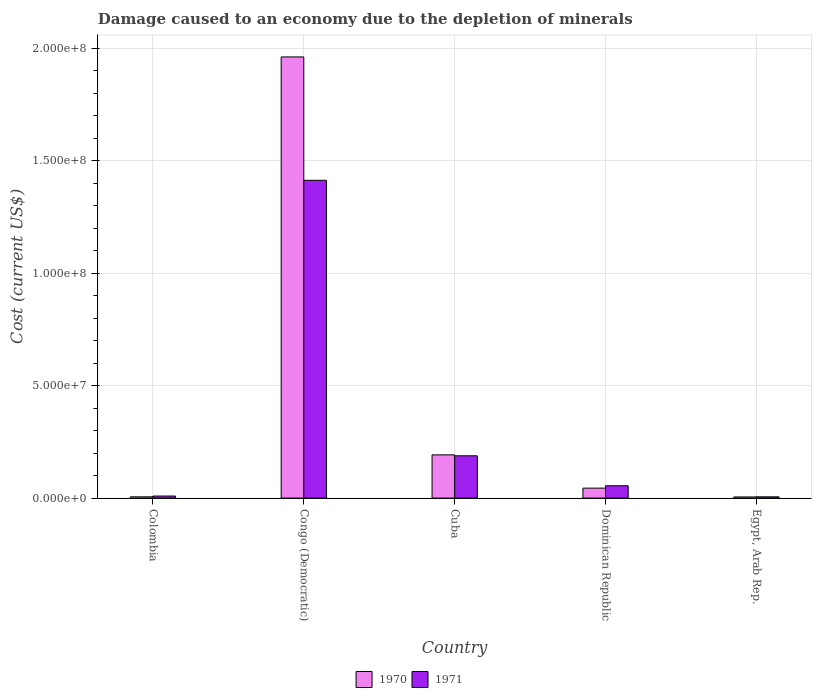How many different coloured bars are there?
Your response must be concise. 2. Are the number of bars on each tick of the X-axis equal?
Offer a very short reply. Yes. How many bars are there on the 5th tick from the right?
Offer a terse response. 2. What is the label of the 5th group of bars from the left?
Offer a terse response. Egypt, Arab Rep. What is the cost of damage caused due to the depletion of minerals in 1971 in Egypt, Arab Rep.?
Offer a very short reply. 5.55e+05. Across all countries, what is the maximum cost of damage caused due to the depletion of minerals in 1971?
Your answer should be compact. 1.41e+08. Across all countries, what is the minimum cost of damage caused due to the depletion of minerals in 1970?
Provide a short and direct response. 5.07e+05. In which country was the cost of damage caused due to the depletion of minerals in 1970 maximum?
Your answer should be very brief. Congo (Democratic). In which country was the cost of damage caused due to the depletion of minerals in 1970 minimum?
Make the answer very short. Egypt, Arab Rep. What is the total cost of damage caused due to the depletion of minerals in 1971 in the graph?
Offer a very short reply. 1.67e+08. What is the difference between the cost of damage caused due to the depletion of minerals in 1971 in Congo (Democratic) and that in Egypt, Arab Rep.?
Ensure brevity in your answer.  1.41e+08. What is the difference between the cost of damage caused due to the depletion of minerals in 1971 in Colombia and the cost of damage caused due to the depletion of minerals in 1970 in Cuba?
Your answer should be very brief. -1.83e+07. What is the average cost of damage caused due to the depletion of minerals in 1971 per country?
Provide a succinct answer. 3.34e+07. What is the difference between the cost of damage caused due to the depletion of minerals of/in 1970 and cost of damage caused due to the depletion of minerals of/in 1971 in Cuba?
Your answer should be very brief. 4.14e+05. In how many countries, is the cost of damage caused due to the depletion of minerals in 1971 greater than 150000000 US$?
Offer a terse response. 0. What is the ratio of the cost of damage caused due to the depletion of minerals in 1970 in Colombia to that in Egypt, Arab Rep.?
Your response must be concise. 1.09. Is the difference between the cost of damage caused due to the depletion of minerals in 1970 in Congo (Democratic) and Egypt, Arab Rep. greater than the difference between the cost of damage caused due to the depletion of minerals in 1971 in Congo (Democratic) and Egypt, Arab Rep.?
Your response must be concise. Yes. What is the difference between the highest and the second highest cost of damage caused due to the depletion of minerals in 1970?
Provide a short and direct response. -1.77e+08. What is the difference between the highest and the lowest cost of damage caused due to the depletion of minerals in 1971?
Ensure brevity in your answer.  1.41e+08. What does the 1st bar from the left in Congo (Democratic) represents?
Provide a short and direct response. 1970. What does the 2nd bar from the right in Congo (Democratic) represents?
Provide a succinct answer. 1970. How many bars are there?
Ensure brevity in your answer.  10. Are all the bars in the graph horizontal?
Give a very brief answer. No. How many countries are there in the graph?
Ensure brevity in your answer.  5. Are the values on the major ticks of Y-axis written in scientific E-notation?
Give a very brief answer. Yes. Does the graph contain grids?
Keep it short and to the point. Yes. Where does the legend appear in the graph?
Your response must be concise. Bottom center. How many legend labels are there?
Your answer should be compact. 2. What is the title of the graph?
Make the answer very short. Damage caused to an economy due to the depletion of minerals. Does "1962" appear as one of the legend labels in the graph?
Keep it short and to the point. No. What is the label or title of the Y-axis?
Keep it short and to the point. Cost (current US$). What is the Cost (current US$) of 1970 in Colombia?
Provide a short and direct response. 5.53e+05. What is the Cost (current US$) of 1971 in Colombia?
Your answer should be compact. 9.12e+05. What is the Cost (current US$) in 1970 in Congo (Democratic)?
Ensure brevity in your answer.  1.96e+08. What is the Cost (current US$) in 1971 in Congo (Democratic)?
Provide a short and direct response. 1.41e+08. What is the Cost (current US$) in 1970 in Cuba?
Provide a succinct answer. 1.92e+07. What is the Cost (current US$) of 1971 in Cuba?
Give a very brief answer. 1.88e+07. What is the Cost (current US$) of 1970 in Dominican Republic?
Make the answer very short. 4.43e+06. What is the Cost (current US$) in 1971 in Dominican Republic?
Your answer should be very brief. 5.48e+06. What is the Cost (current US$) of 1970 in Egypt, Arab Rep.?
Your answer should be very brief. 5.07e+05. What is the Cost (current US$) in 1971 in Egypt, Arab Rep.?
Give a very brief answer. 5.55e+05. Across all countries, what is the maximum Cost (current US$) in 1970?
Your answer should be compact. 1.96e+08. Across all countries, what is the maximum Cost (current US$) in 1971?
Ensure brevity in your answer.  1.41e+08. Across all countries, what is the minimum Cost (current US$) in 1970?
Your answer should be very brief. 5.07e+05. Across all countries, what is the minimum Cost (current US$) of 1971?
Provide a short and direct response. 5.55e+05. What is the total Cost (current US$) of 1970 in the graph?
Your answer should be very brief. 2.21e+08. What is the total Cost (current US$) in 1971 in the graph?
Offer a terse response. 1.67e+08. What is the difference between the Cost (current US$) of 1970 in Colombia and that in Congo (Democratic)?
Keep it short and to the point. -1.96e+08. What is the difference between the Cost (current US$) in 1971 in Colombia and that in Congo (Democratic)?
Your response must be concise. -1.40e+08. What is the difference between the Cost (current US$) in 1970 in Colombia and that in Cuba?
Your response must be concise. -1.87e+07. What is the difference between the Cost (current US$) in 1971 in Colombia and that in Cuba?
Provide a short and direct response. -1.79e+07. What is the difference between the Cost (current US$) of 1970 in Colombia and that in Dominican Republic?
Keep it short and to the point. -3.87e+06. What is the difference between the Cost (current US$) of 1971 in Colombia and that in Dominican Republic?
Ensure brevity in your answer.  -4.57e+06. What is the difference between the Cost (current US$) of 1970 in Colombia and that in Egypt, Arab Rep.?
Offer a terse response. 4.53e+04. What is the difference between the Cost (current US$) in 1971 in Colombia and that in Egypt, Arab Rep.?
Your answer should be compact. 3.57e+05. What is the difference between the Cost (current US$) of 1970 in Congo (Democratic) and that in Cuba?
Your answer should be very brief. 1.77e+08. What is the difference between the Cost (current US$) in 1971 in Congo (Democratic) and that in Cuba?
Give a very brief answer. 1.23e+08. What is the difference between the Cost (current US$) in 1970 in Congo (Democratic) and that in Dominican Republic?
Your answer should be very brief. 1.92e+08. What is the difference between the Cost (current US$) of 1971 in Congo (Democratic) and that in Dominican Republic?
Your answer should be compact. 1.36e+08. What is the difference between the Cost (current US$) of 1970 in Congo (Democratic) and that in Egypt, Arab Rep.?
Give a very brief answer. 1.96e+08. What is the difference between the Cost (current US$) of 1971 in Congo (Democratic) and that in Egypt, Arab Rep.?
Offer a very short reply. 1.41e+08. What is the difference between the Cost (current US$) of 1970 in Cuba and that in Dominican Republic?
Your answer should be compact. 1.48e+07. What is the difference between the Cost (current US$) of 1971 in Cuba and that in Dominican Republic?
Your answer should be compact. 1.33e+07. What is the difference between the Cost (current US$) in 1970 in Cuba and that in Egypt, Arab Rep.?
Offer a terse response. 1.87e+07. What is the difference between the Cost (current US$) in 1971 in Cuba and that in Egypt, Arab Rep.?
Ensure brevity in your answer.  1.83e+07. What is the difference between the Cost (current US$) of 1970 in Dominican Republic and that in Egypt, Arab Rep.?
Offer a very short reply. 3.92e+06. What is the difference between the Cost (current US$) of 1971 in Dominican Republic and that in Egypt, Arab Rep.?
Give a very brief answer. 4.92e+06. What is the difference between the Cost (current US$) of 1970 in Colombia and the Cost (current US$) of 1971 in Congo (Democratic)?
Ensure brevity in your answer.  -1.41e+08. What is the difference between the Cost (current US$) of 1970 in Colombia and the Cost (current US$) of 1971 in Cuba?
Make the answer very short. -1.83e+07. What is the difference between the Cost (current US$) in 1970 in Colombia and the Cost (current US$) in 1971 in Dominican Republic?
Provide a short and direct response. -4.93e+06. What is the difference between the Cost (current US$) in 1970 in Colombia and the Cost (current US$) in 1971 in Egypt, Arab Rep.?
Ensure brevity in your answer.  -2551.4. What is the difference between the Cost (current US$) in 1970 in Congo (Democratic) and the Cost (current US$) in 1971 in Cuba?
Provide a succinct answer. 1.77e+08. What is the difference between the Cost (current US$) in 1970 in Congo (Democratic) and the Cost (current US$) in 1971 in Dominican Republic?
Your answer should be very brief. 1.91e+08. What is the difference between the Cost (current US$) of 1970 in Congo (Democratic) and the Cost (current US$) of 1971 in Egypt, Arab Rep.?
Provide a short and direct response. 1.96e+08. What is the difference between the Cost (current US$) in 1970 in Cuba and the Cost (current US$) in 1971 in Dominican Republic?
Offer a very short reply. 1.37e+07. What is the difference between the Cost (current US$) in 1970 in Cuba and the Cost (current US$) in 1971 in Egypt, Arab Rep.?
Your response must be concise. 1.87e+07. What is the difference between the Cost (current US$) of 1970 in Dominican Republic and the Cost (current US$) of 1971 in Egypt, Arab Rep.?
Provide a short and direct response. 3.87e+06. What is the average Cost (current US$) in 1970 per country?
Provide a short and direct response. 4.42e+07. What is the average Cost (current US$) of 1971 per country?
Make the answer very short. 3.34e+07. What is the difference between the Cost (current US$) in 1970 and Cost (current US$) in 1971 in Colombia?
Give a very brief answer. -3.59e+05. What is the difference between the Cost (current US$) of 1970 and Cost (current US$) of 1971 in Congo (Democratic)?
Ensure brevity in your answer.  5.49e+07. What is the difference between the Cost (current US$) of 1970 and Cost (current US$) of 1971 in Cuba?
Give a very brief answer. 4.14e+05. What is the difference between the Cost (current US$) in 1970 and Cost (current US$) in 1971 in Dominican Republic?
Your answer should be very brief. -1.05e+06. What is the difference between the Cost (current US$) in 1970 and Cost (current US$) in 1971 in Egypt, Arab Rep.?
Ensure brevity in your answer.  -4.79e+04. What is the ratio of the Cost (current US$) in 1970 in Colombia to that in Congo (Democratic)?
Give a very brief answer. 0. What is the ratio of the Cost (current US$) in 1971 in Colombia to that in Congo (Democratic)?
Make the answer very short. 0.01. What is the ratio of the Cost (current US$) in 1970 in Colombia to that in Cuba?
Your answer should be very brief. 0.03. What is the ratio of the Cost (current US$) of 1971 in Colombia to that in Cuba?
Provide a succinct answer. 0.05. What is the ratio of the Cost (current US$) of 1970 in Colombia to that in Dominican Republic?
Provide a succinct answer. 0.12. What is the ratio of the Cost (current US$) of 1971 in Colombia to that in Dominican Republic?
Provide a succinct answer. 0.17. What is the ratio of the Cost (current US$) of 1970 in Colombia to that in Egypt, Arab Rep.?
Provide a succinct answer. 1.09. What is the ratio of the Cost (current US$) in 1971 in Colombia to that in Egypt, Arab Rep.?
Provide a short and direct response. 1.64. What is the ratio of the Cost (current US$) in 1970 in Congo (Democratic) to that in Cuba?
Your answer should be compact. 10.21. What is the ratio of the Cost (current US$) in 1971 in Congo (Democratic) to that in Cuba?
Give a very brief answer. 7.51. What is the ratio of the Cost (current US$) in 1970 in Congo (Democratic) to that in Dominican Republic?
Give a very brief answer. 44.31. What is the ratio of the Cost (current US$) of 1971 in Congo (Democratic) to that in Dominican Republic?
Keep it short and to the point. 25.8. What is the ratio of the Cost (current US$) of 1970 in Congo (Democratic) to that in Egypt, Arab Rep.?
Give a very brief answer. 386.71. What is the ratio of the Cost (current US$) of 1971 in Congo (Democratic) to that in Egypt, Arab Rep.?
Give a very brief answer. 254.55. What is the ratio of the Cost (current US$) in 1970 in Cuba to that in Dominican Republic?
Give a very brief answer. 4.34. What is the ratio of the Cost (current US$) of 1971 in Cuba to that in Dominican Republic?
Your answer should be very brief. 3.43. What is the ratio of the Cost (current US$) of 1970 in Cuba to that in Egypt, Arab Rep.?
Your answer should be compact. 37.89. What is the ratio of the Cost (current US$) of 1971 in Cuba to that in Egypt, Arab Rep.?
Your response must be concise. 33.88. What is the ratio of the Cost (current US$) in 1970 in Dominican Republic to that in Egypt, Arab Rep.?
Ensure brevity in your answer.  8.73. What is the ratio of the Cost (current US$) of 1971 in Dominican Republic to that in Egypt, Arab Rep.?
Offer a very short reply. 9.87. What is the difference between the highest and the second highest Cost (current US$) in 1970?
Your answer should be very brief. 1.77e+08. What is the difference between the highest and the second highest Cost (current US$) in 1971?
Make the answer very short. 1.23e+08. What is the difference between the highest and the lowest Cost (current US$) of 1970?
Offer a terse response. 1.96e+08. What is the difference between the highest and the lowest Cost (current US$) of 1971?
Provide a succinct answer. 1.41e+08. 